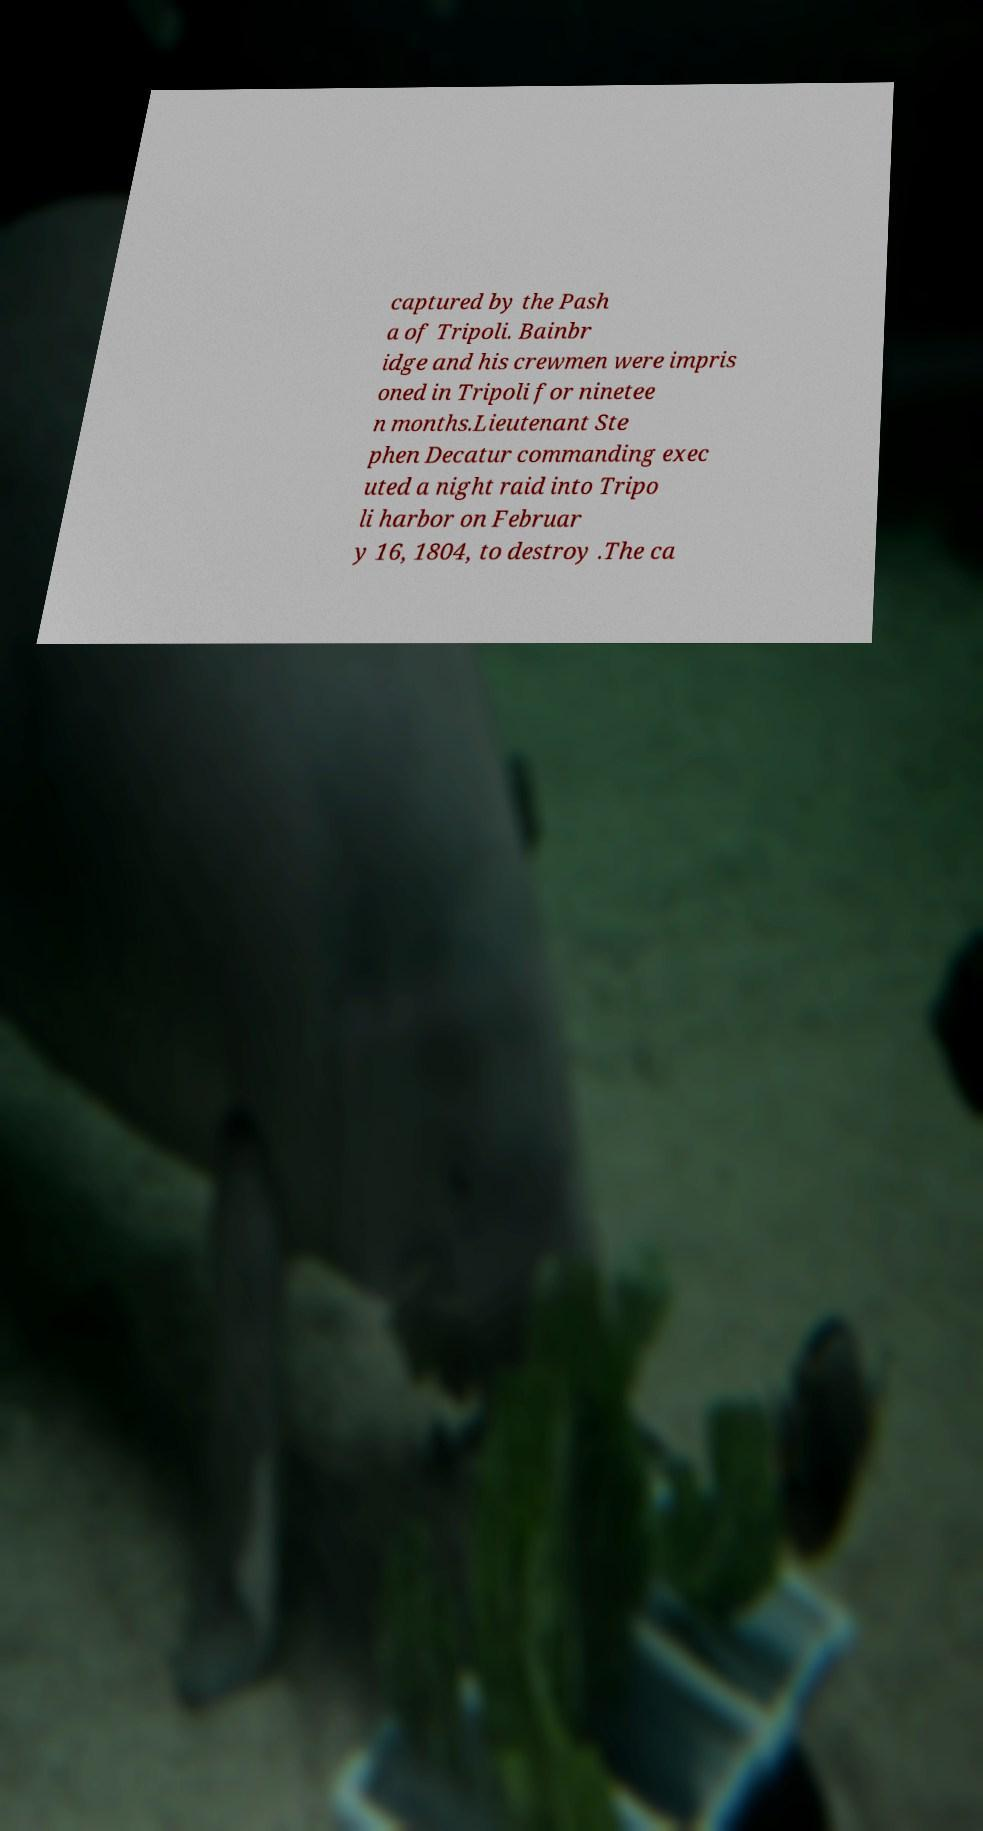What messages or text are displayed in this image? I need them in a readable, typed format. captured by the Pash a of Tripoli. Bainbr idge and his crewmen were impris oned in Tripoli for ninetee n months.Lieutenant Ste phen Decatur commanding exec uted a night raid into Tripo li harbor on Februar y 16, 1804, to destroy .The ca 